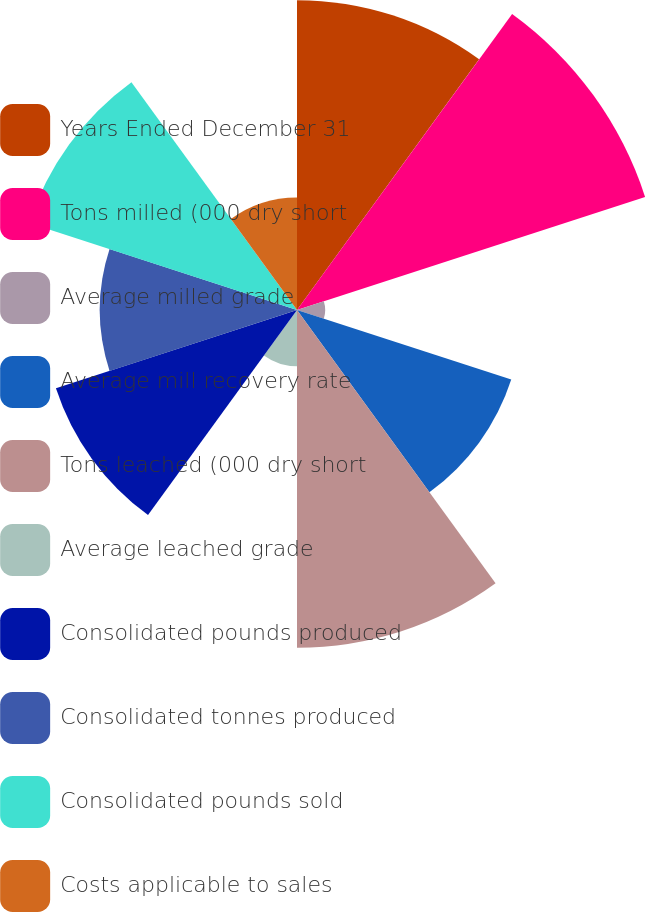<chart> <loc_0><loc_0><loc_500><loc_500><pie_chart><fcel>Years Ended December 31<fcel>Tons milled (000 dry short<fcel>Average milled grade<fcel>Average mill recovery rate<fcel>Tons leached (000 dry short<fcel>Average leached grade<fcel>Consolidated pounds produced<fcel>Consolidated tonnes produced<fcel>Consolidated pounds sold<fcel>Costs applicable to sales<nl><fcel>14.29%<fcel>16.88%<fcel>1.3%<fcel>10.39%<fcel>15.58%<fcel>2.6%<fcel>11.69%<fcel>9.09%<fcel>12.99%<fcel>5.19%<nl></chart> 